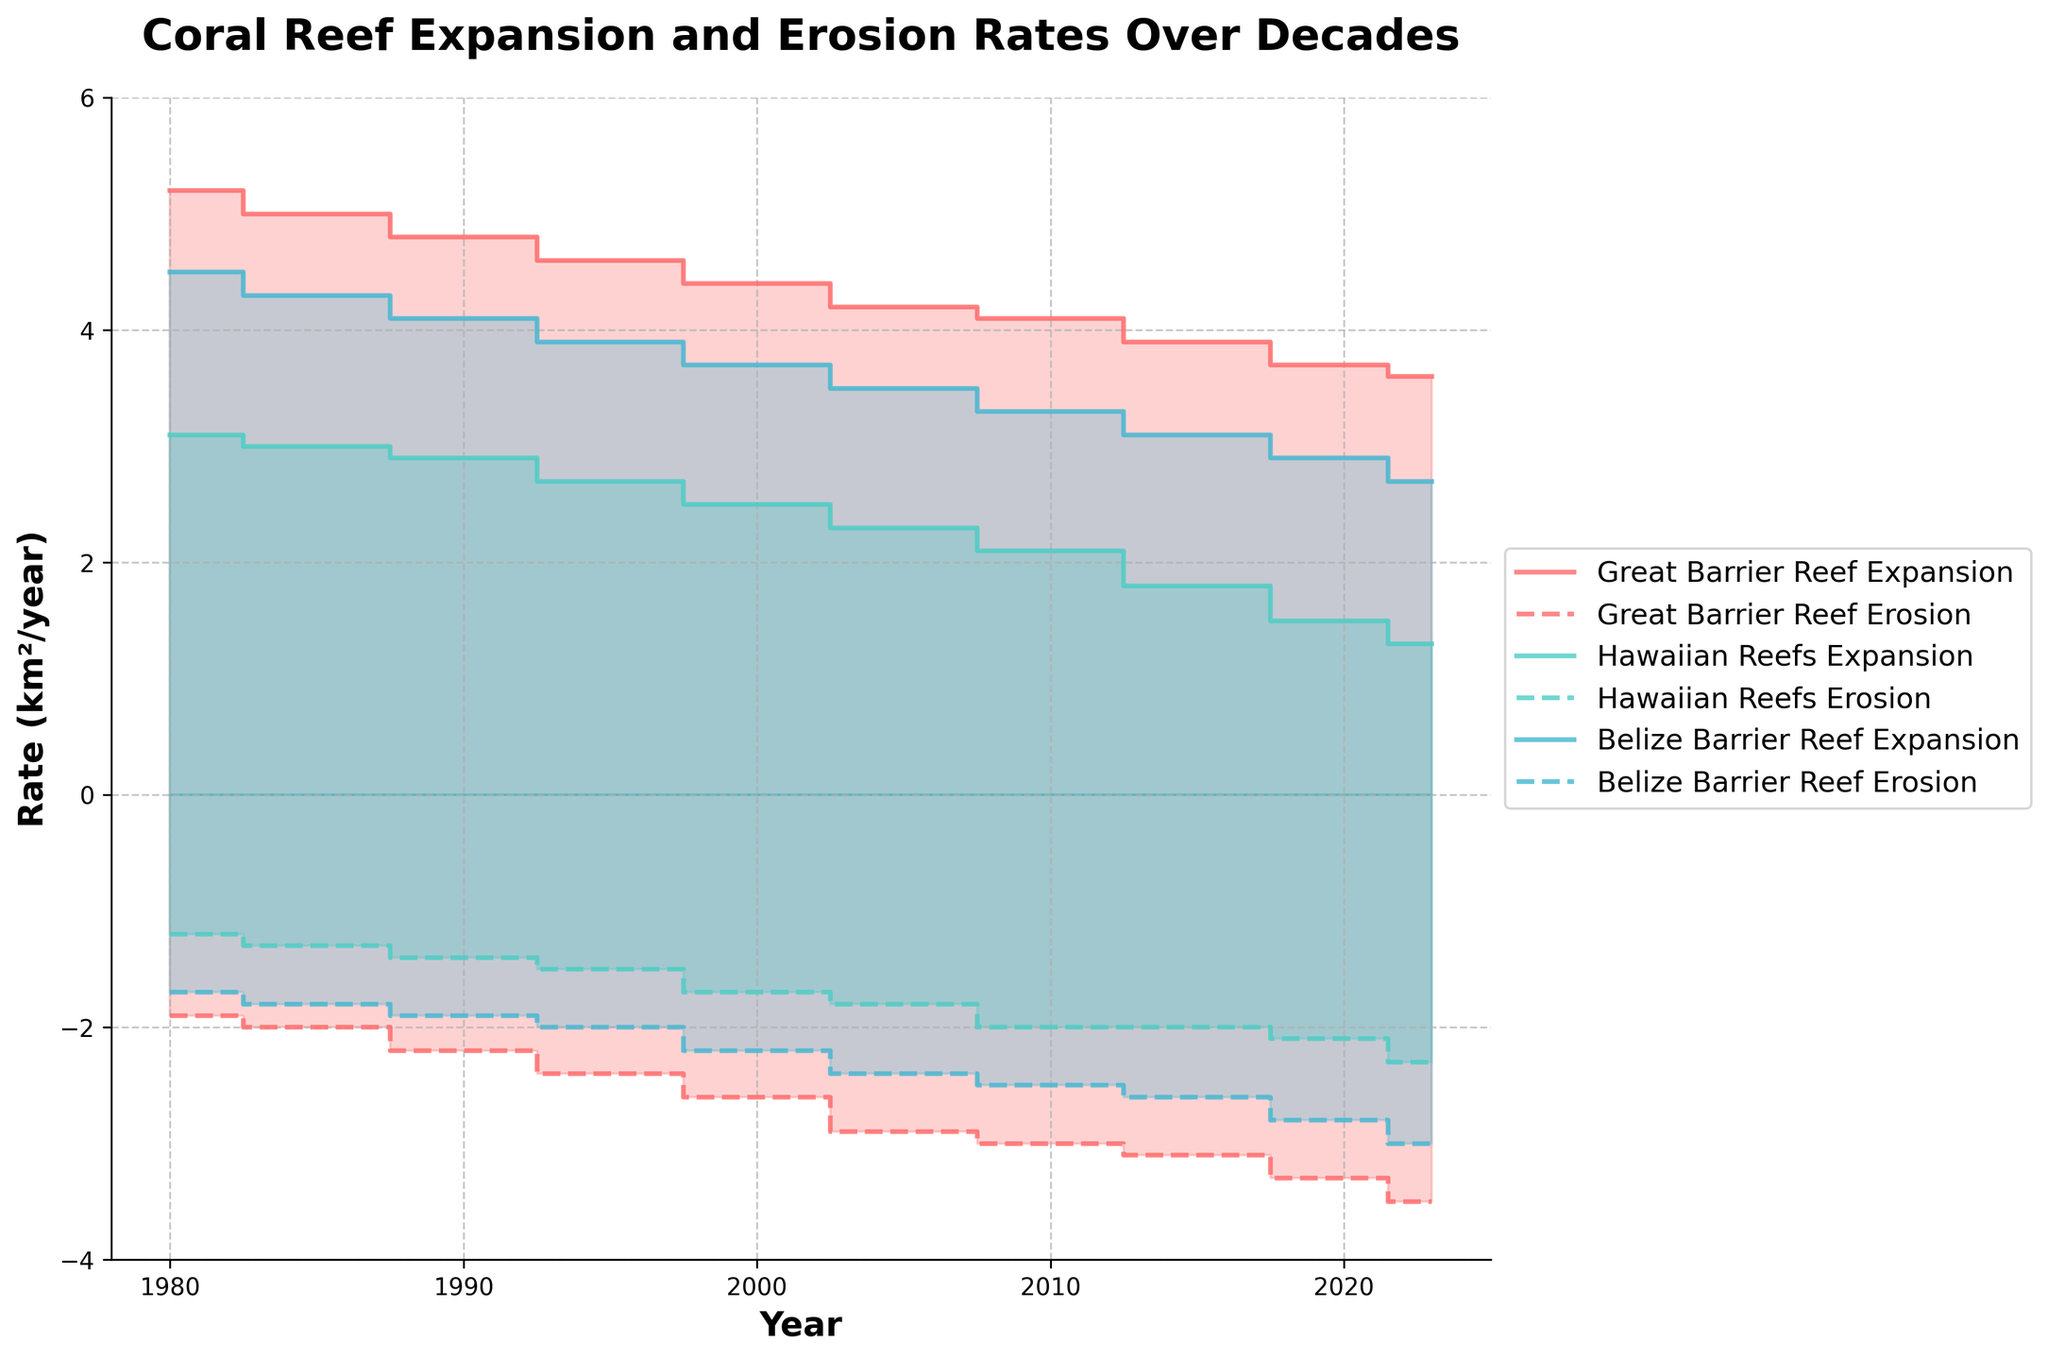What is the title of the figure? The title is written at the top of the figure, displaying the main theme of the chart.
Answer: Coral Reef Expansion and Erosion Rates Over Decades What are the years shown on the x-axis? The x-axis typically shows the years covered in the dataset, arranged from left to right.
Answer: 1980 to 2023 Which reef experienced the highest expansion rate in 1980? By examining the step area sections corresponding to 1980, we can compare the values of the expansion rates for each reef.
Answer: Great Barrier Reef In which year was the erosion rate of the Belize Barrier Reef the highest? Looking at the step area sections where the erosion values are plotted (below the x-axis), identify the year where the Belize Barrier Reef erosion rate is the maximum.
Answer: 2023 How do the erosion rates of the Great Barrier Reef and Hawaiian Reefs compare in 2005? Locate the values for both reefs' erosion rates in 2005 and compare them by looking at the step area below the x-axis.
Answer: Great Barrier Reef > Hawaiian Reefs Calculate the difference between the expansion and erosion rates of the Great Barrier Reef in 2020. Identify the expansion and erosion rates for the Great Barrier Reef in 2020, then compute the difference by subtracting the erosion rate from the expansion rate.
Answer: 0.4 km²/year Which reef shows the most significant decline in expansion rate between 1980 and 2023? Compare the expansion rates of each reef in 1980 and 2023, then determine the reef with the largest reduction.
Answer: Great Barrier Reef What is the general trend of the erosion rates for all reefs from 1980 to 2023? Observe the step areas below the x-axis for each reef across the years to identify whether the erosion rates are generally increasing, decreasing, or remaining constant.
Answer: Increasing Compare the combined expansion and erosion rates of Hawaiian Reefs in 1990. Which one is higher? Add the Hawaiian Reefs' expansion and erosion rates separately in 1990 and compare the two sums.
Answer: Expansion rate 